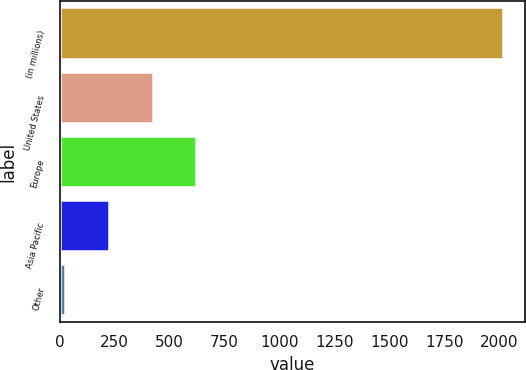Convert chart. <chart><loc_0><loc_0><loc_500><loc_500><bar_chart><fcel>(in millions)<fcel>United States<fcel>Europe<fcel>Asia Pacific<fcel>Other<nl><fcel>2015<fcel>423.8<fcel>622.7<fcel>224.9<fcel>26<nl></chart> 